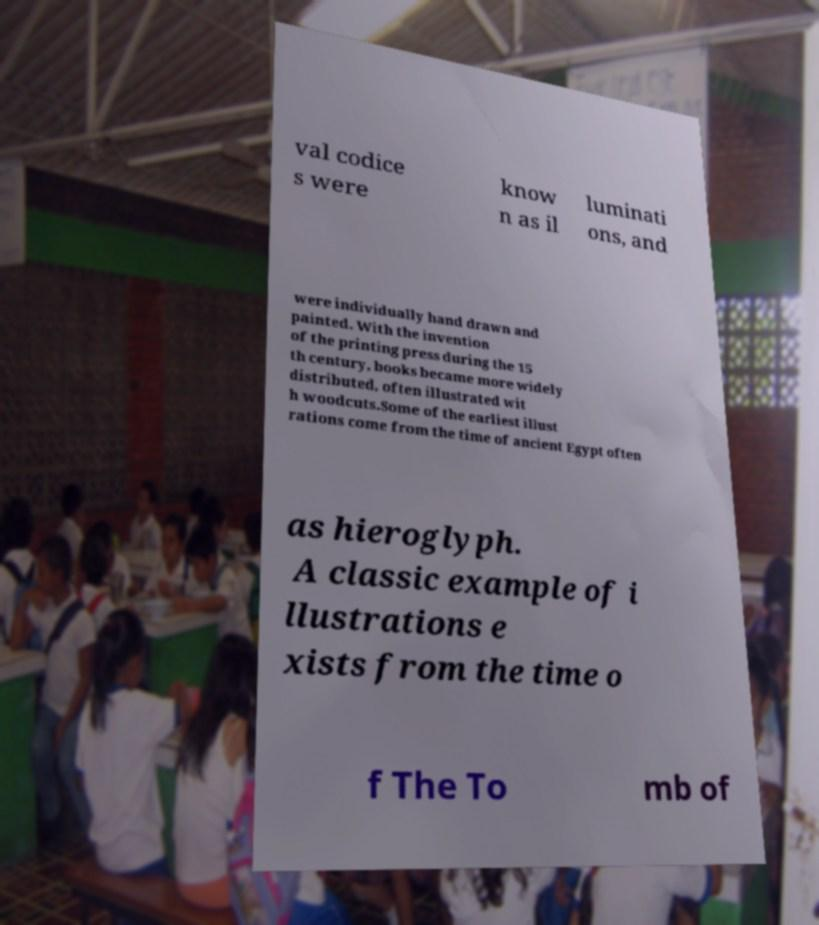I need the written content from this picture converted into text. Can you do that? val codice s were know n as il luminati ons, and were individually hand drawn and painted. With the invention of the printing press during the 15 th century, books became more widely distributed, often illustrated wit h woodcuts.Some of the earliest illust rations come from the time of ancient Egypt often as hieroglyph. A classic example of i llustrations e xists from the time o f The To mb of 